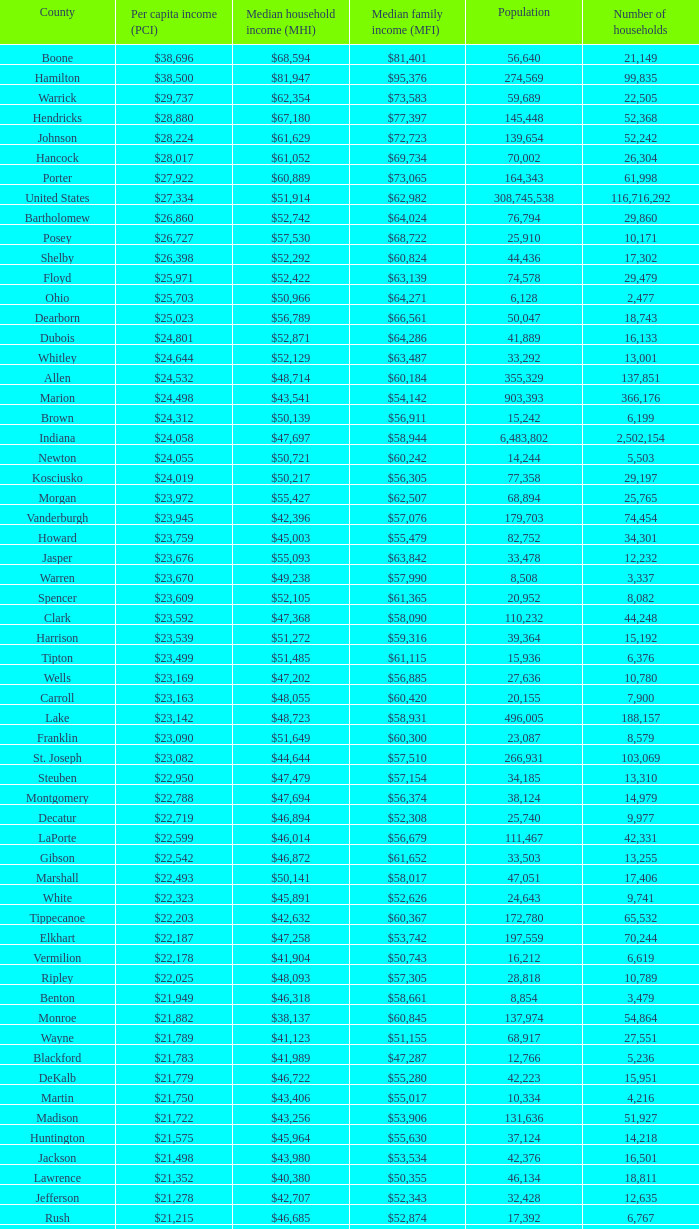What County has a Median household income of $46,872? Gibson. 